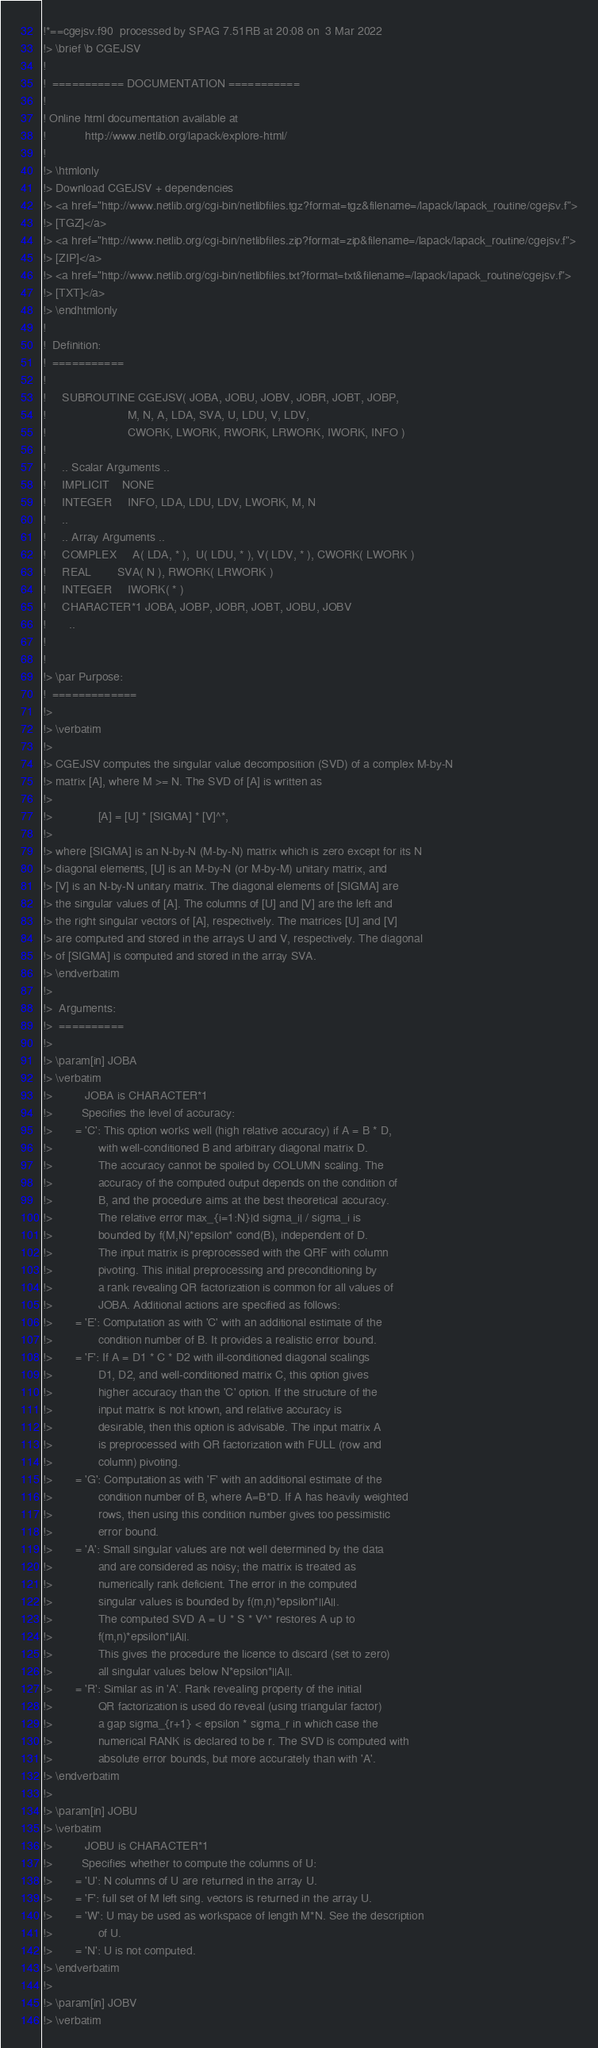<code> <loc_0><loc_0><loc_500><loc_500><_FORTRAN_>!*==cgejsv.f90  processed by SPAG 7.51RB at 20:08 on  3 Mar 2022
!> \brief \b CGEJSV
!
!  =========== DOCUMENTATION ===========
!
! Online html documentation available at
!            http://www.netlib.org/lapack/explore-html/
!
!> \htmlonly
!> Download CGEJSV + dependencies
!> <a href="http://www.netlib.org/cgi-bin/netlibfiles.tgz?format=tgz&filename=/lapack/lapack_routine/cgejsv.f">
!> [TGZ]</a>
!> <a href="http://www.netlib.org/cgi-bin/netlibfiles.zip?format=zip&filename=/lapack/lapack_routine/cgejsv.f">
!> [ZIP]</a>
!> <a href="http://www.netlib.org/cgi-bin/netlibfiles.txt?format=txt&filename=/lapack/lapack_routine/cgejsv.f">
!> [TXT]</a>
!> \endhtmlonly
!
!  Definition:
!  ===========
!
!     SUBROUTINE CGEJSV( JOBA, JOBU, JOBV, JOBR, JOBT, JOBP,
!                         M, N, A, LDA, SVA, U, LDU, V, LDV,
!                         CWORK, LWORK, RWORK, LRWORK, IWORK, INFO )
!
!     .. Scalar Arguments ..
!     IMPLICIT    NONE
!     INTEGER     INFO, LDA, LDU, LDV, LWORK, M, N
!     ..
!     .. Array Arguments ..
!     COMPLEX     A( LDA, * ),  U( LDU, * ), V( LDV, * ), CWORK( LWORK )
!     REAL        SVA( N ), RWORK( LRWORK )
!     INTEGER     IWORK( * )
!     CHARACTER*1 JOBA, JOBP, JOBR, JOBT, JOBU, JOBV
!       ..
!
!
!> \par Purpose:
!  =============
!>
!> \verbatim
!>
!> CGEJSV computes the singular value decomposition (SVD) of a complex M-by-N
!> matrix [A], where M >= N. The SVD of [A] is written as
!>
!>              [A] = [U] * [SIGMA] * [V]^*,
!>
!> where [SIGMA] is an N-by-N (M-by-N) matrix which is zero except for its N
!> diagonal elements, [U] is an M-by-N (or M-by-M) unitary matrix, and
!> [V] is an N-by-N unitary matrix. The diagonal elements of [SIGMA] are
!> the singular values of [A]. The columns of [U] and [V] are the left and
!> the right singular vectors of [A], respectively. The matrices [U] and [V]
!> are computed and stored in the arrays U and V, respectively. The diagonal
!> of [SIGMA] is computed and stored in the array SVA.
!> \endverbatim
!>
!>  Arguments:
!>  ==========
!>
!> \param[in] JOBA
!> \verbatim
!>          JOBA is CHARACTER*1
!>         Specifies the level of accuracy:
!>       = 'C': This option works well (high relative accuracy) if A = B * D,
!>              with well-conditioned B and arbitrary diagonal matrix D.
!>              The accuracy cannot be spoiled by COLUMN scaling. The
!>              accuracy of the computed output depends on the condition of
!>              B, and the procedure aims at the best theoretical accuracy.
!>              The relative error max_{i=1:N}|d sigma_i| / sigma_i is
!>              bounded by f(M,N)*epsilon* cond(B), independent of D.
!>              The input matrix is preprocessed with the QRF with column
!>              pivoting. This initial preprocessing and preconditioning by
!>              a rank revealing QR factorization is common for all values of
!>              JOBA. Additional actions are specified as follows:
!>       = 'E': Computation as with 'C' with an additional estimate of the
!>              condition number of B. It provides a realistic error bound.
!>       = 'F': If A = D1 * C * D2 with ill-conditioned diagonal scalings
!>              D1, D2, and well-conditioned matrix C, this option gives
!>              higher accuracy than the 'C' option. If the structure of the
!>              input matrix is not known, and relative accuracy is
!>              desirable, then this option is advisable. The input matrix A
!>              is preprocessed with QR factorization with FULL (row and
!>              column) pivoting.
!>       = 'G': Computation as with 'F' with an additional estimate of the
!>              condition number of B, where A=B*D. If A has heavily weighted
!>              rows, then using this condition number gives too pessimistic
!>              error bound.
!>       = 'A': Small singular values are not well determined by the data
!>              and are considered as noisy; the matrix is treated as
!>              numerically rank deficient. The error in the computed
!>              singular values is bounded by f(m,n)*epsilon*||A||.
!>              The computed SVD A = U * S * V^* restores A up to
!>              f(m,n)*epsilon*||A||.
!>              This gives the procedure the licence to discard (set to zero)
!>              all singular values below N*epsilon*||A||.
!>       = 'R': Similar as in 'A'. Rank revealing property of the initial
!>              QR factorization is used do reveal (using triangular factor)
!>              a gap sigma_{r+1} < epsilon * sigma_r in which case the
!>              numerical RANK is declared to be r. The SVD is computed with
!>              absolute error bounds, but more accurately than with 'A'.
!> \endverbatim
!>
!> \param[in] JOBU
!> \verbatim
!>          JOBU is CHARACTER*1
!>         Specifies whether to compute the columns of U:
!>       = 'U': N columns of U are returned in the array U.
!>       = 'F': full set of M left sing. vectors is returned in the array U.
!>       = 'W': U may be used as workspace of length M*N. See the description
!>              of U.
!>       = 'N': U is not computed.
!> \endverbatim
!>
!> \param[in] JOBV
!> \verbatim</code> 